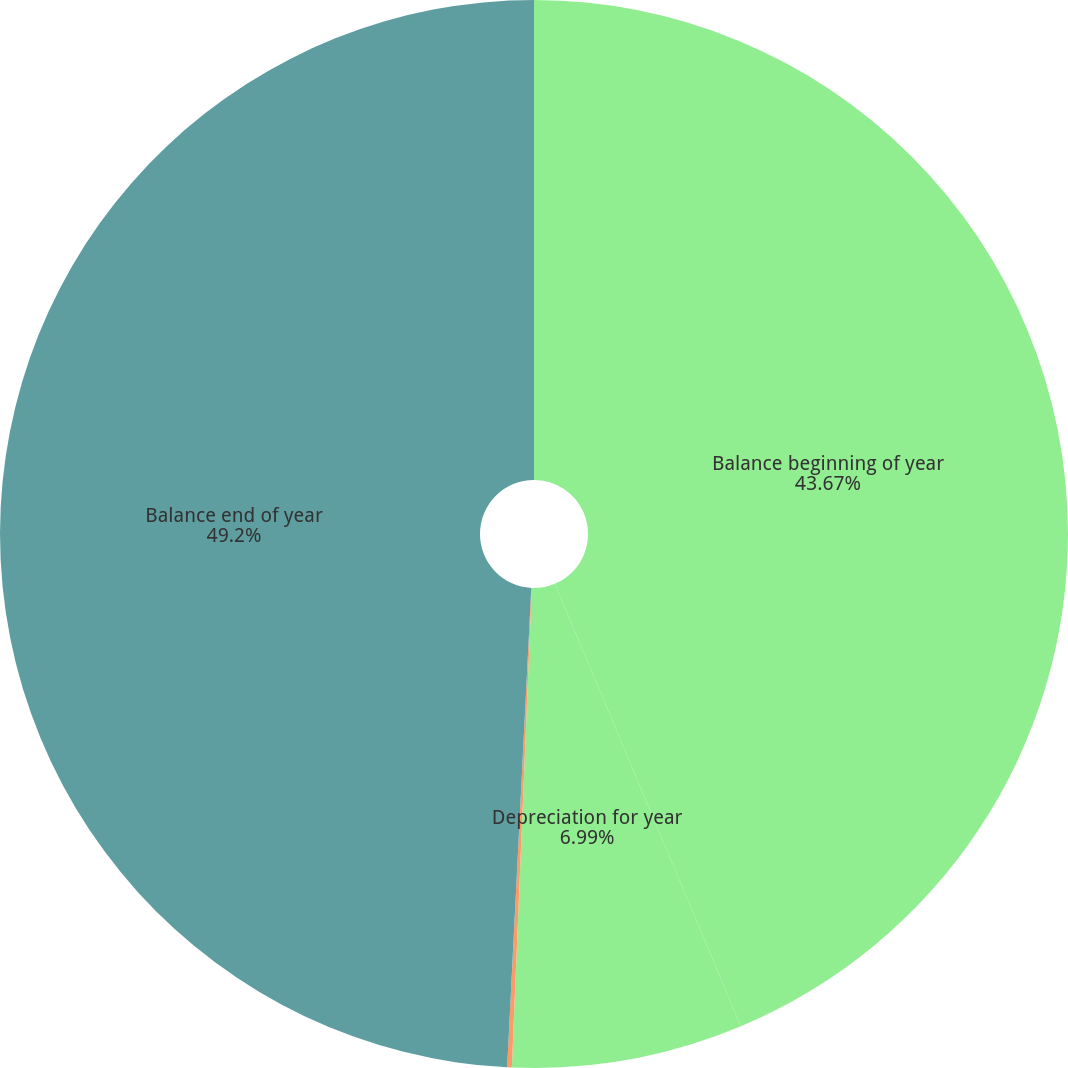<chart> <loc_0><loc_0><loc_500><loc_500><pie_chart><fcel>Balance beginning of year<fcel>Depreciation for year<fcel>Sale of properties<fcel>Balance end of year<nl><fcel>43.67%<fcel>6.99%<fcel>0.14%<fcel>49.2%<nl></chart> 